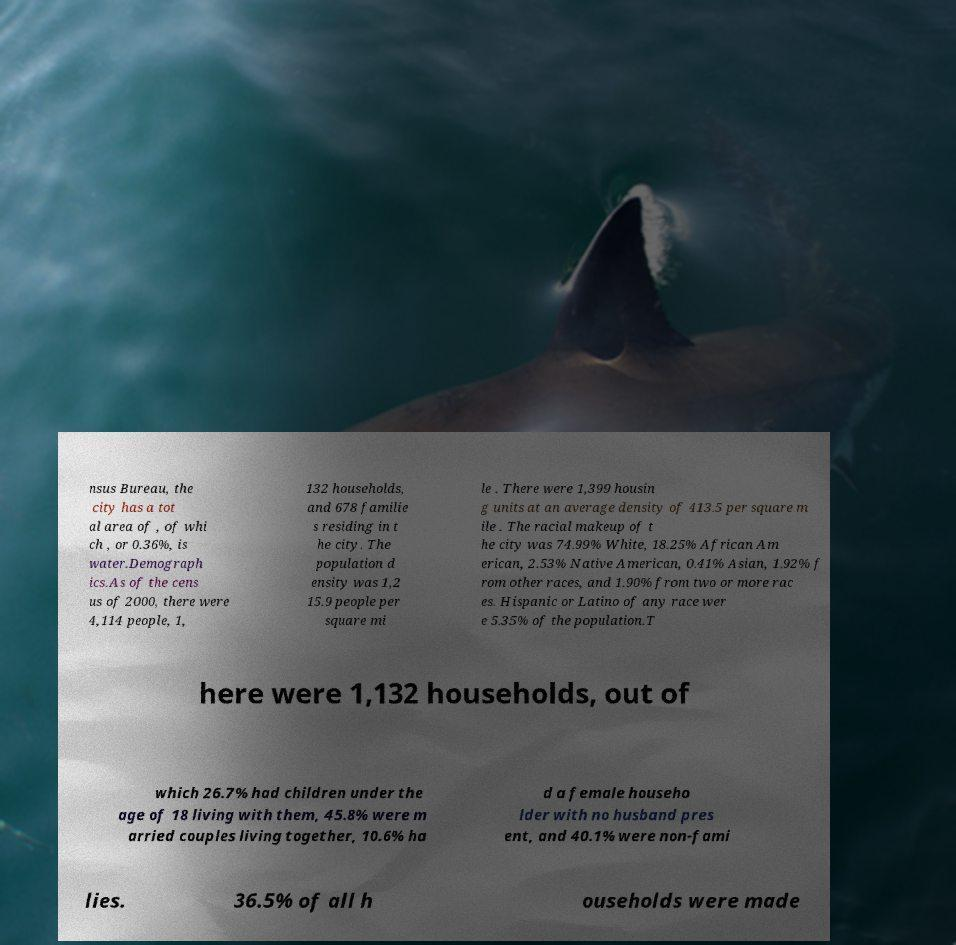Please read and relay the text visible in this image. What does it say? nsus Bureau, the city has a tot al area of , of whi ch , or 0.36%, is water.Demograph ics.As of the cens us of 2000, there were 4,114 people, 1, 132 households, and 678 familie s residing in t he city. The population d ensity was 1,2 15.9 people per square mi le . There were 1,399 housin g units at an average density of 413.5 per square m ile . The racial makeup of t he city was 74.99% White, 18.25% African Am erican, 2.53% Native American, 0.41% Asian, 1.92% f rom other races, and 1.90% from two or more rac es. Hispanic or Latino of any race wer e 5.35% of the population.T here were 1,132 households, out of which 26.7% had children under the age of 18 living with them, 45.8% were m arried couples living together, 10.6% ha d a female househo lder with no husband pres ent, and 40.1% were non-fami lies. 36.5% of all h ouseholds were made 